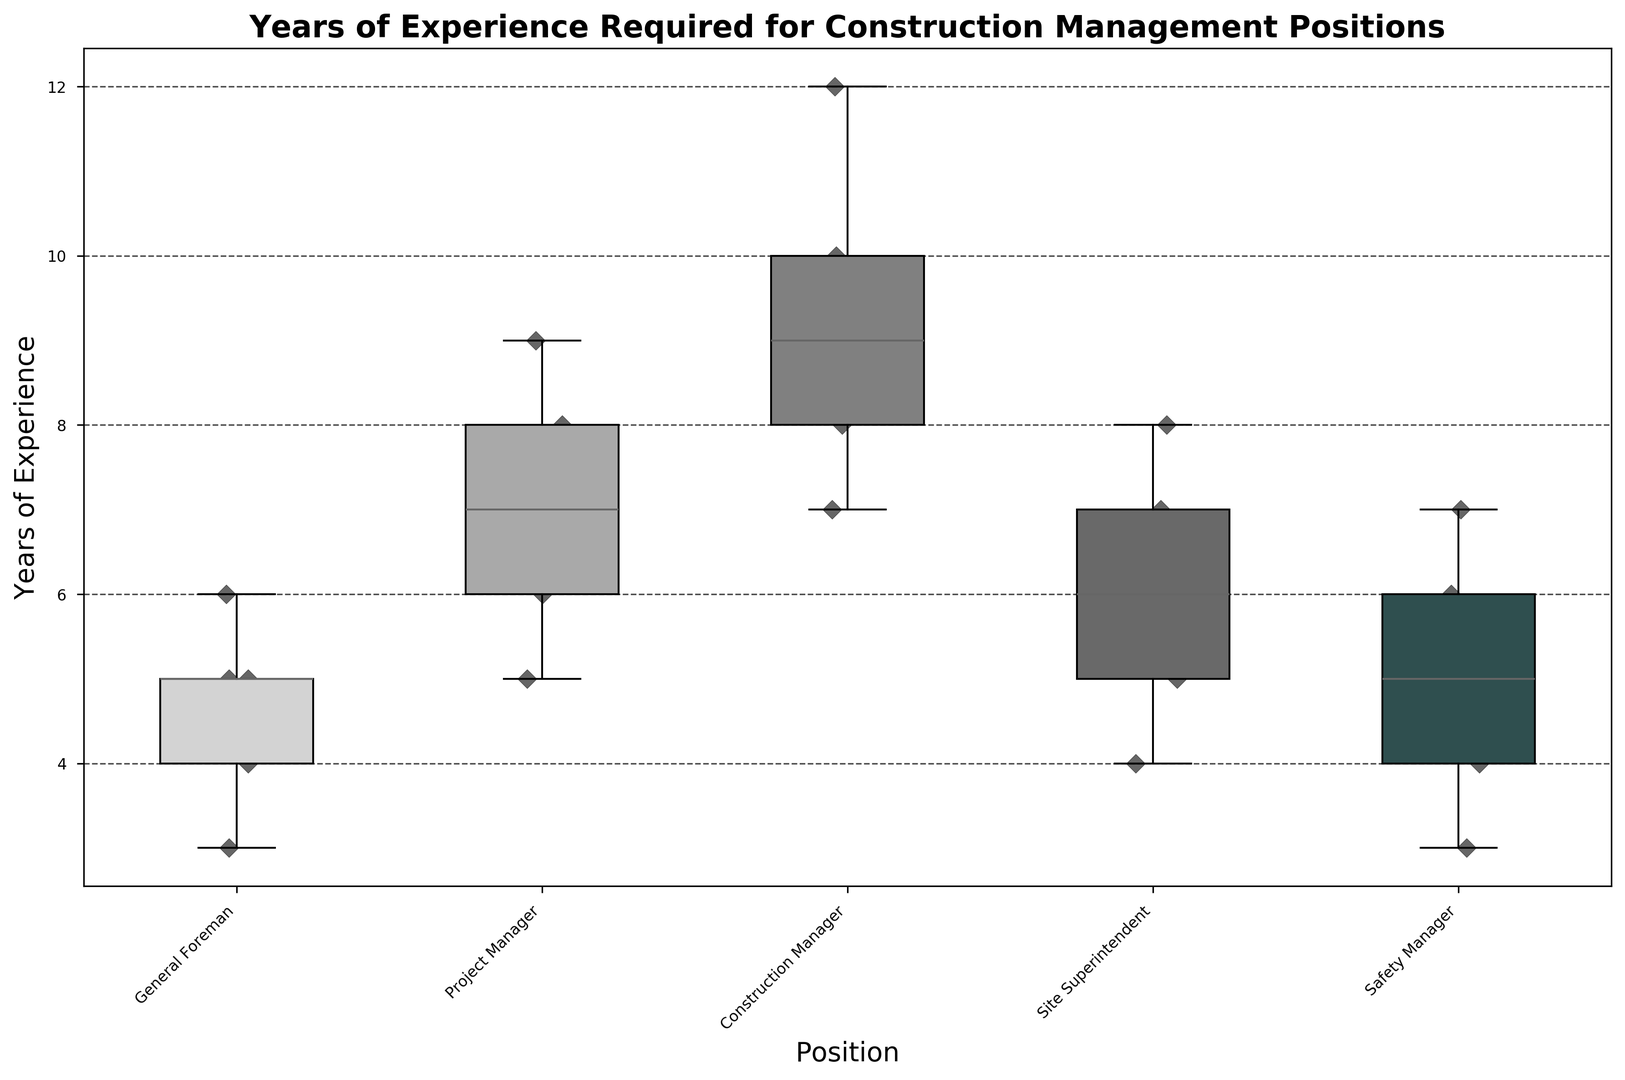What is the median years of experience required for a Site Superintendent? To find the median for Site Superintendent, locate the middle value when the data is arranged in ascending order. The values are 4, 5, 6, 7, 8. The middle number is 6.
Answer: 6 Which position requires the most years of experience on average? Calculate the average years of experience for each position and compare. Construction Manager has values 7, 8, 9, 10, 12. The sum is 46, divided by 5 gives 9.2. Other averages are lower.
Answer: Construction Manager Is the variation in experience required for a General Foreman smaller or larger than that for a Project Manager? Compare the interquartile ranges (height of the boxes) in the box plot for both positions. General Foreman has a range from 4 to 6, and Project Manager from 6 to 9. Project Manager has a larger variation.
Answer: Larger Which position has the widest distribution of years of experience required? Observe the box plot and find the position with the longest whiskers. Construction Manager extends from 7 to 12, which is the widest distribution.
Answer: Construction Manager What is the minimum experience required for a Safety Manager? Look at the lower whisker of the box plot for Safety Manager. The minimum value is at 3.
Answer: 3 Which position has the highest median years of experience? Identify the median lines (horizontal line inside the box) of each position. Construction Manager's median is highest, at 9.
Answer: Construction Manager Compare the experience required for the 25th percentile for General Foreman and Safety Manager. The 25th percentile is where the lower edge of the box is located. For General Foreman, it is 4; for Safety Manager, it is 4. Both are the same.
Answer: Equal What is the range of years of experience required for a Project Manager? The range is calculated by subtracting the smallest value from the largest value. For Project Manager, the values are 5 (minimum) and 9 (maximum). The range is 9 - 5 = 4.
Answer: 4 Does the Site Superintendent position require more experience on average than the General Foreman? Compare the average years of experience for both positions. General Foreman has an average of (3+4+5+5+6)/5=4.6. Site Superintendent has an average of (4+5+6+7+8)/5=6. The average is higher for Site Superintendent.
Answer: Yes Which position requires at least 10 years of experience for the upper quartile? Locate the upper quartile (top edge of the box) for each position. Construction Manager's upper quartile is 10.
Answer: Construction Manager 